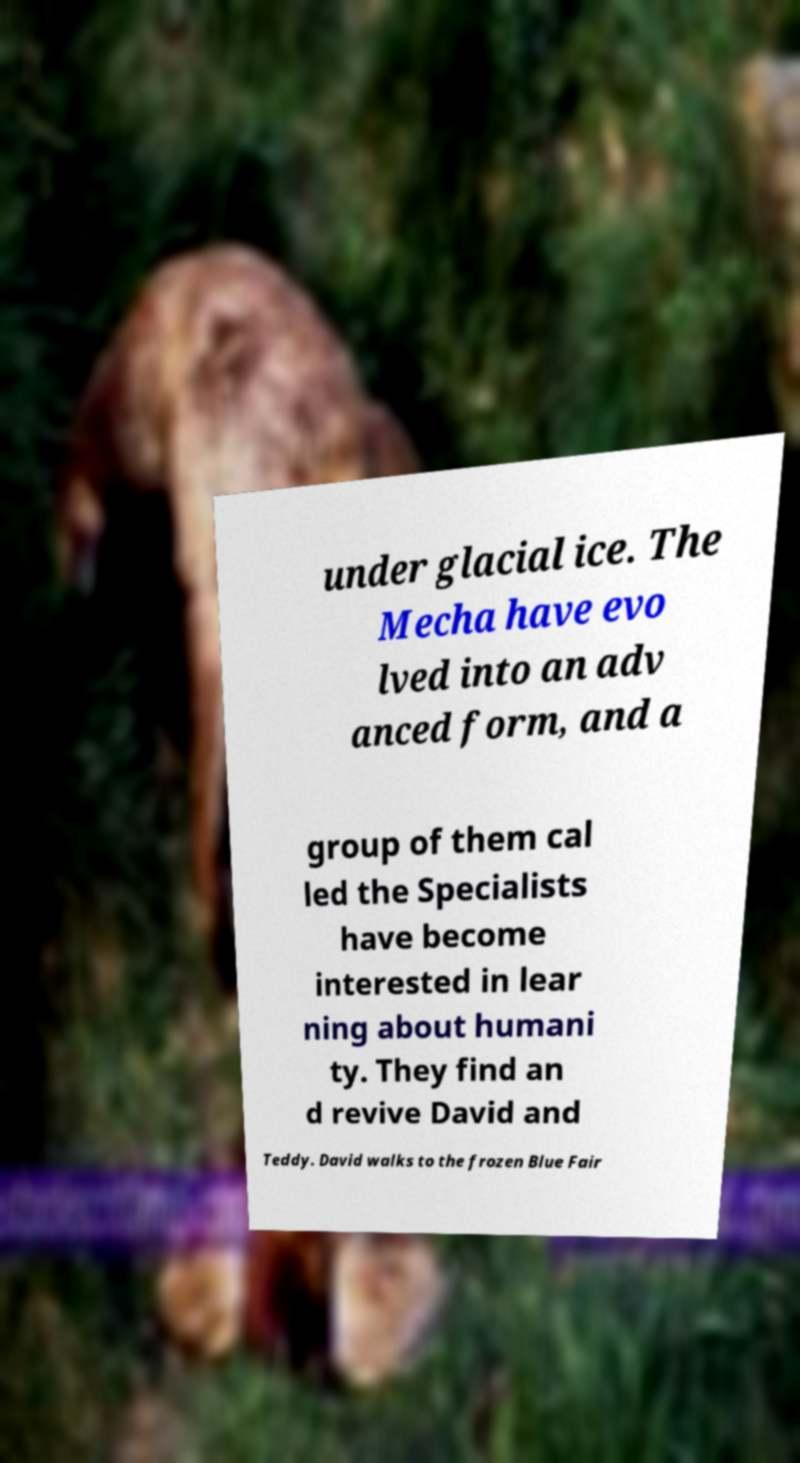Could you assist in decoding the text presented in this image and type it out clearly? under glacial ice. The Mecha have evo lved into an adv anced form, and a group of them cal led the Specialists have become interested in lear ning about humani ty. They find an d revive David and Teddy. David walks to the frozen Blue Fair 